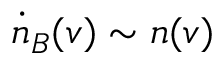Convert formula to latex. <formula><loc_0><loc_0><loc_500><loc_500>\dot { n } _ { B } ( v ) \sim n ( v )</formula> 